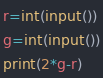Convert code to text. <code><loc_0><loc_0><loc_500><loc_500><_Python_>r=int(input())
g=int(input())
print(2*g-r)</code> 